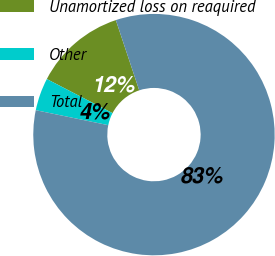Convert chart to OTSL. <chart><loc_0><loc_0><loc_500><loc_500><pie_chart><fcel>Unamortized loss on reaquired<fcel>Other<fcel>Total<nl><fcel>12.27%<fcel>4.37%<fcel>83.37%<nl></chart> 